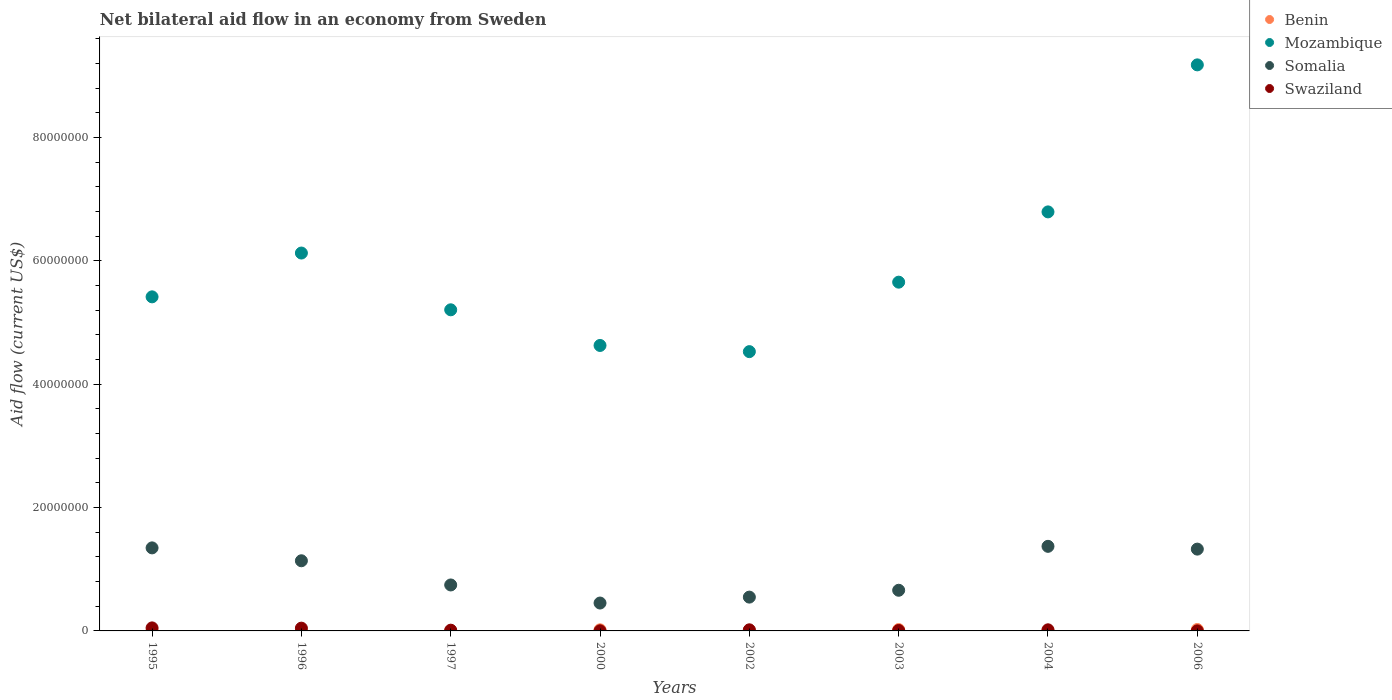Is the number of dotlines equal to the number of legend labels?
Make the answer very short. Yes. What is the net bilateral aid flow in Somalia in 1997?
Ensure brevity in your answer.  7.45e+06. Across all years, what is the maximum net bilateral aid flow in Benin?
Ensure brevity in your answer.  2.30e+05. Across all years, what is the minimum net bilateral aid flow in Mozambique?
Keep it short and to the point. 4.53e+07. In which year was the net bilateral aid flow in Somalia minimum?
Ensure brevity in your answer.  2000. What is the total net bilateral aid flow in Benin in the graph?
Offer a very short reply. 8.80e+05. What is the difference between the net bilateral aid flow in Mozambique in 1996 and that in 2003?
Your answer should be very brief. 4.72e+06. What is the difference between the net bilateral aid flow in Swaziland in 2004 and the net bilateral aid flow in Somalia in 1997?
Offer a terse response. -7.27e+06. What is the average net bilateral aid flow in Mozambique per year?
Make the answer very short. 5.94e+07. In the year 1996, what is the difference between the net bilateral aid flow in Benin and net bilateral aid flow in Somalia?
Your answer should be compact. -1.14e+07. In how many years, is the net bilateral aid flow in Benin greater than 84000000 US$?
Ensure brevity in your answer.  0. What is the ratio of the net bilateral aid flow in Somalia in 1997 to that in 2000?
Your answer should be compact. 1.65. What is the difference between the highest and the second highest net bilateral aid flow in Benin?
Provide a succinct answer. 10000. What is the difference between the highest and the lowest net bilateral aid flow in Mozambique?
Make the answer very short. 4.65e+07. Is the sum of the net bilateral aid flow in Mozambique in 1997 and 2000 greater than the maximum net bilateral aid flow in Somalia across all years?
Provide a succinct answer. Yes. Is it the case that in every year, the sum of the net bilateral aid flow in Benin and net bilateral aid flow in Swaziland  is greater than the sum of net bilateral aid flow in Mozambique and net bilateral aid flow in Somalia?
Provide a short and direct response. No. Does the net bilateral aid flow in Benin monotonically increase over the years?
Make the answer very short. No. Is the net bilateral aid flow in Benin strictly less than the net bilateral aid flow in Somalia over the years?
Offer a terse response. Yes. How many years are there in the graph?
Provide a short and direct response. 8. Does the graph contain grids?
Your answer should be compact. No. Where does the legend appear in the graph?
Provide a succinct answer. Top right. What is the title of the graph?
Provide a short and direct response. Net bilateral aid flow in an economy from Sweden. What is the label or title of the X-axis?
Provide a short and direct response. Years. What is the Aid flow (current US$) of Benin in 1995?
Offer a terse response. 5.00e+04. What is the Aid flow (current US$) of Mozambique in 1995?
Your response must be concise. 5.42e+07. What is the Aid flow (current US$) of Somalia in 1995?
Offer a terse response. 1.35e+07. What is the Aid flow (current US$) in Benin in 1996?
Ensure brevity in your answer.  10000. What is the Aid flow (current US$) in Mozambique in 1996?
Offer a terse response. 6.12e+07. What is the Aid flow (current US$) of Somalia in 1996?
Give a very brief answer. 1.14e+07. What is the Aid flow (current US$) of Swaziland in 1996?
Provide a succinct answer. 4.50e+05. What is the Aid flow (current US$) in Mozambique in 1997?
Your answer should be very brief. 5.20e+07. What is the Aid flow (current US$) of Somalia in 1997?
Give a very brief answer. 7.45e+06. What is the Aid flow (current US$) of Swaziland in 1997?
Give a very brief answer. 1.20e+05. What is the Aid flow (current US$) of Benin in 2000?
Your answer should be compact. 1.80e+05. What is the Aid flow (current US$) of Mozambique in 2000?
Offer a terse response. 4.63e+07. What is the Aid flow (current US$) in Somalia in 2000?
Offer a very short reply. 4.52e+06. What is the Aid flow (current US$) in Swaziland in 2000?
Provide a short and direct response. 2.00e+04. What is the Aid flow (current US$) in Mozambique in 2002?
Provide a succinct answer. 4.53e+07. What is the Aid flow (current US$) in Somalia in 2002?
Your answer should be compact. 5.48e+06. What is the Aid flow (current US$) of Swaziland in 2002?
Keep it short and to the point. 1.80e+05. What is the Aid flow (current US$) in Benin in 2003?
Offer a terse response. 2.20e+05. What is the Aid flow (current US$) of Mozambique in 2003?
Your answer should be very brief. 5.65e+07. What is the Aid flow (current US$) in Somalia in 2003?
Provide a short and direct response. 6.59e+06. What is the Aid flow (current US$) of Swaziland in 2003?
Provide a succinct answer. 7.00e+04. What is the Aid flow (current US$) in Benin in 2004?
Make the answer very short. 9.00e+04. What is the Aid flow (current US$) of Mozambique in 2004?
Your answer should be compact. 6.79e+07. What is the Aid flow (current US$) of Somalia in 2004?
Make the answer very short. 1.37e+07. What is the Aid flow (current US$) in Swaziland in 2004?
Provide a short and direct response. 1.80e+05. What is the Aid flow (current US$) of Benin in 2006?
Your response must be concise. 2.30e+05. What is the Aid flow (current US$) in Mozambique in 2006?
Offer a terse response. 9.18e+07. What is the Aid flow (current US$) of Somalia in 2006?
Make the answer very short. 1.33e+07. Across all years, what is the maximum Aid flow (current US$) of Mozambique?
Offer a terse response. 9.18e+07. Across all years, what is the maximum Aid flow (current US$) in Somalia?
Offer a terse response. 1.37e+07. Across all years, what is the minimum Aid flow (current US$) of Mozambique?
Make the answer very short. 4.53e+07. Across all years, what is the minimum Aid flow (current US$) in Somalia?
Provide a short and direct response. 4.52e+06. What is the total Aid flow (current US$) in Benin in the graph?
Provide a short and direct response. 8.80e+05. What is the total Aid flow (current US$) in Mozambique in the graph?
Your response must be concise. 4.75e+08. What is the total Aid flow (current US$) in Somalia in the graph?
Make the answer very short. 7.58e+07. What is the total Aid flow (current US$) of Swaziland in the graph?
Provide a succinct answer. 1.52e+06. What is the difference between the Aid flow (current US$) in Benin in 1995 and that in 1996?
Give a very brief answer. 4.00e+04. What is the difference between the Aid flow (current US$) in Mozambique in 1995 and that in 1996?
Offer a very short reply. -7.10e+06. What is the difference between the Aid flow (current US$) of Somalia in 1995 and that in 1996?
Ensure brevity in your answer.  2.09e+06. What is the difference between the Aid flow (current US$) of Swaziland in 1995 and that in 1996?
Make the answer very short. 4.00e+04. What is the difference between the Aid flow (current US$) in Benin in 1995 and that in 1997?
Your answer should be compact. 4.00e+04. What is the difference between the Aid flow (current US$) of Mozambique in 1995 and that in 1997?
Your response must be concise. 2.10e+06. What is the difference between the Aid flow (current US$) of Somalia in 1995 and that in 1997?
Keep it short and to the point. 6.01e+06. What is the difference between the Aid flow (current US$) of Swaziland in 1995 and that in 1997?
Your answer should be compact. 3.70e+05. What is the difference between the Aid flow (current US$) of Mozambique in 1995 and that in 2000?
Make the answer very short. 7.88e+06. What is the difference between the Aid flow (current US$) of Somalia in 1995 and that in 2000?
Your answer should be very brief. 8.94e+06. What is the difference between the Aid flow (current US$) in Benin in 1995 and that in 2002?
Your answer should be very brief. -4.00e+04. What is the difference between the Aid flow (current US$) in Mozambique in 1995 and that in 2002?
Offer a terse response. 8.88e+06. What is the difference between the Aid flow (current US$) in Somalia in 1995 and that in 2002?
Your answer should be very brief. 7.98e+06. What is the difference between the Aid flow (current US$) of Swaziland in 1995 and that in 2002?
Offer a terse response. 3.10e+05. What is the difference between the Aid flow (current US$) of Mozambique in 1995 and that in 2003?
Make the answer very short. -2.38e+06. What is the difference between the Aid flow (current US$) of Somalia in 1995 and that in 2003?
Offer a very short reply. 6.87e+06. What is the difference between the Aid flow (current US$) in Benin in 1995 and that in 2004?
Give a very brief answer. -4.00e+04. What is the difference between the Aid flow (current US$) in Mozambique in 1995 and that in 2004?
Keep it short and to the point. -1.38e+07. What is the difference between the Aid flow (current US$) of Somalia in 1995 and that in 2004?
Give a very brief answer. -2.50e+05. What is the difference between the Aid flow (current US$) of Benin in 1995 and that in 2006?
Offer a terse response. -1.80e+05. What is the difference between the Aid flow (current US$) in Mozambique in 1995 and that in 2006?
Offer a terse response. -3.76e+07. What is the difference between the Aid flow (current US$) in Somalia in 1995 and that in 2006?
Your response must be concise. 2.00e+05. What is the difference between the Aid flow (current US$) in Swaziland in 1995 and that in 2006?
Provide a succinct answer. 4.80e+05. What is the difference between the Aid flow (current US$) in Benin in 1996 and that in 1997?
Offer a terse response. 0. What is the difference between the Aid flow (current US$) of Mozambique in 1996 and that in 1997?
Your answer should be compact. 9.20e+06. What is the difference between the Aid flow (current US$) in Somalia in 1996 and that in 1997?
Offer a terse response. 3.92e+06. What is the difference between the Aid flow (current US$) of Swaziland in 1996 and that in 1997?
Give a very brief answer. 3.30e+05. What is the difference between the Aid flow (current US$) of Benin in 1996 and that in 2000?
Ensure brevity in your answer.  -1.70e+05. What is the difference between the Aid flow (current US$) in Mozambique in 1996 and that in 2000?
Offer a terse response. 1.50e+07. What is the difference between the Aid flow (current US$) of Somalia in 1996 and that in 2000?
Your answer should be very brief. 6.85e+06. What is the difference between the Aid flow (current US$) in Swaziland in 1996 and that in 2000?
Offer a very short reply. 4.30e+05. What is the difference between the Aid flow (current US$) of Mozambique in 1996 and that in 2002?
Provide a short and direct response. 1.60e+07. What is the difference between the Aid flow (current US$) of Somalia in 1996 and that in 2002?
Provide a succinct answer. 5.89e+06. What is the difference between the Aid flow (current US$) of Mozambique in 1996 and that in 2003?
Your response must be concise. 4.72e+06. What is the difference between the Aid flow (current US$) of Somalia in 1996 and that in 2003?
Your answer should be compact. 4.78e+06. What is the difference between the Aid flow (current US$) in Mozambique in 1996 and that in 2004?
Provide a succinct answer. -6.67e+06. What is the difference between the Aid flow (current US$) in Somalia in 1996 and that in 2004?
Offer a very short reply. -2.34e+06. What is the difference between the Aid flow (current US$) of Benin in 1996 and that in 2006?
Ensure brevity in your answer.  -2.20e+05. What is the difference between the Aid flow (current US$) in Mozambique in 1996 and that in 2006?
Your answer should be very brief. -3.05e+07. What is the difference between the Aid flow (current US$) in Somalia in 1996 and that in 2006?
Give a very brief answer. -1.89e+06. What is the difference between the Aid flow (current US$) in Mozambique in 1997 and that in 2000?
Provide a succinct answer. 5.78e+06. What is the difference between the Aid flow (current US$) of Somalia in 1997 and that in 2000?
Ensure brevity in your answer.  2.93e+06. What is the difference between the Aid flow (current US$) in Swaziland in 1997 and that in 2000?
Your answer should be compact. 1.00e+05. What is the difference between the Aid flow (current US$) of Benin in 1997 and that in 2002?
Offer a terse response. -8.00e+04. What is the difference between the Aid flow (current US$) in Mozambique in 1997 and that in 2002?
Your answer should be very brief. 6.78e+06. What is the difference between the Aid flow (current US$) in Somalia in 1997 and that in 2002?
Keep it short and to the point. 1.97e+06. What is the difference between the Aid flow (current US$) of Benin in 1997 and that in 2003?
Offer a very short reply. -2.10e+05. What is the difference between the Aid flow (current US$) in Mozambique in 1997 and that in 2003?
Provide a short and direct response. -4.48e+06. What is the difference between the Aid flow (current US$) in Somalia in 1997 and that in 2003?
Offer a very short reply. 8.60e+05. What is the difference between the Aid flow (current US$) of Mozambique in 1997 and that in 2004?
Your response must be concise. -1.59e+07. What is the difference between the Aid flow (current US$) in Somalia in 1997 and that in 2004?
Offer a very short reply. -6.26e+06. What is the difference between the Aid flow (current US$) of Benin in 1997 and that in 2006?
Provide a short and direct response. -2.20e+05. What is the difference between the Aid flow (current US$) of Mozambique in 1997 and that in 2006?
Ensure brevity in your answer.  -3.97e+07. What is the difference between the Aid flow (current US$) of Somalia in 1997 and that in 2006?
Your answer should be compact. -5.81e+06. What is the difference between the Aid flow (current US$) of Somalia in 2000 and that in 2002?
Keep it short and to the point. -9.60e+05. What is the difference between the Aid flow (current US$) of Swaziland in 2000 and that in 2002?
Offer a terse response. -1.60e+05. What is the difference between the Aid flow (current US$) of Benin in 2000 and that in 2003?
Give a very brief answer. -4.00e+04. What is the difference between the Aid flow (current US$) in Mozambique in 2000 and that in 2003?
Give a very brief answer. -1.03e+07. What is the difference between the Aid flow (current US$) of Somalia in 2000 and that in 2003?
Offer a terse response. -2.07e+06. What is the difference between the Aid flow (current US$) in Mozambique in 2000 and that in 2004?
Your answer should be compact. -2.16e+07. What is the difference between the Aid flow (current US$) of Somalia in 2000 and that in 2004?
Offer a terse response. -9.19e+06. What is the difference between the Aid flow (current US$) of Benin in 2000 and that in 2006?
Your answer should be very brief. -5.00e+04. What is the difference between the Aid flow (current US$) in Mozambique in 2000 and that in 2006?
Make the answer very short. -4.55e+07. What is the difference between the Aid flow (current US$) in Somalia in 2000 and that in 2006?
Your answer should be compact. -8.74e+06. What is the difference between the Aid flow (current US$) of Swaziland in 2000 and that in 2006?
Your response must be concise. 10000. What is the difference between the Aid flow (current US$) of Mozambique in 2002 and that in 2003?
Make the answer very short. -1.13e+07. What is the difference between the Aid flow (current US$) in Somalia in 2002 and that in 2003?
Your answer should be compact. -1.11e+06. What is the difference between the Aid flow (current US$) of Benin in 2002 and that in 2004?
Provide a short and direct response. 0. What is the difference between the Aid flow (current US$) of Mozambique in 2002 and that in 2004?
Your answer should be compact. -2.26e+07. What is the difference between the Aid flow (current US$) of Somalia in 2002 and that in 2004?
Offer a very short reply. -8.23e+06. What is the difference between the Aid flow (current US$) in Swaziland in 2002 and that in 2004?
Offer a terse response. 0. What is the difference between the Aid flow (current US$) of Mozambique in 2002 and that in 2006?
Your answer should be very brief. -4.65e+07. What is the difference between the Aid flow (current US$) in Somalia in 2002 and that in 2006?
Give a very brief answer. -7.78e+06. What is the difference between the Aid flow (current US$) of Swaziland in 2002 and that in 2006?
Provide a short and direct response. 1.70e+05. What is the difference between the Aid flow (current US$) in Benin in 2003 and that in 2004?
Offer a terse response. 1.30e+05. What is the difference between the Aid flow (current US$) in Mozambique in 2003 and that in 2004?
Your answer should be compact. -1.14e+07. What is the difference between the Aid flow (current US$) in Somalia in 2003 and that in 2004?
Provide a short and direct response. -7.12e+06. What is the difference between the Aid flow (current US$) in Benin in 2003 and that in 2006?
Give a very brief answer. -10000. What is the difference between the Aid flow (current US$) of Mozambique in 2003 and that in 2006?
Your response must be concise. -3.52e+07. What is the difference between the Aid flow (current US$) of Somalia in 2003 and that in 2006?
Offer a terse response. -6.67e+06. What is the difference between the Aid flow (current US$) of Swaziland in 2003 and that in 2006?
Your response must be concise. 6.00e+04. What is the difference between the Aid flow (current US$) of Mozambique in 2004 and that in 2006?
Keep it short and to the point. -2.38e+07. What is the difference between the Aid flow (current US$) in Somalia in 2004 and that in 2006?
Ensure brevity in your answer.  4.50e+05. What is the difference between the Aid flow (current US$) in Benin in 1995 and the Aid flow (current US$) in Mozambique in 1996?
Keep it short and to the point. -6.12e+07. What is the difference between the Aid flow (current US$) in Benin in 1995 and the Aid flow (current US$) in Somalia in 1996?
Offer a very short reply. -1.13e+07. What is the difference between the Aid flow (current US$) in Benin in 1995 and the Aid flow (current US$) in Swaziland in 1996?
Offer a terse response. -4.00e+05. What is the difference between the Aid flow (current US$) of Mozambique in 1995 and the Aid flow (current US$) of Somalia in 1996?
Make the answer very short. 4.28e+07. What is the difference between the Aid flow (current US$) in Mozambique in 1995 and the Aid flow (current US$) in Swaziland in 1996?
Your answer should be very brief. 5.37e+07. What is the difference between the Aid flow (current US$) of Somalia in 1995 and the Aid flow (current US$) of Swaziland in 1996?
Ensure brevity in your answer.  1.30e+07. What is the difference between the Aid flow (current US$) of Benin in 1995 and the Aid flow (current US$) of Mozambique in 1997?
Give a very brief answer. -5.20e+07. What is the difference between the Aid flow (current US$) in Benin in 1995 and the Aid flow (current US$) in Somalia in 1997?
Make the answer very short. -7.40e+06. What is the difference between the Aid flow (current US$) of Benin in 1995 and the Aid flow (current US$) of Swaziland in 1997?
Your answer should be very brief. -7.00e+04. What is the difference between the Aid flow (current US$) of Mozambique in 1995 and the Aid flow (current US$) of Somalia in 1997?
Your response must be concise. 4.67e+07. What is the difference between the Aid flow (current US$) of Mozambique in 1995 and the Aid flow (current US$) of Swaziland in 1997?
Keep it short and to the point. 5.40e+07. What is the difference between the Aid flow (current US$) of Somalia in 1995 and the Aid flow (current US$) of Swaziland in 1997?
Provide a succinct answer. 1.33e+07. What is the difference between the Aid flow (current US$) in Benin in 1995 and the Aid flow (current US$) in Mozambique in 2000?
Provide a short and direct response. -4.62e+07. What is the difference between the Aid flow (current US$) in Benin in 1995 and the Aid flow (current US$) in Somalia in 2000?
Your answer should be compact. -4.47e+06. What is the difference between the Aid flow (current US$) in Benin in 1995 and the Aid flow (current US$) in Swaziland in 2000?
Provide a short and direct response. 3.00e+04. What is the difference between the Aid flow (current US$) in Mozambique in 1995 and the Aid flow (current US$) in Somalia in 2000?
Provide a short and direct response. 4.96e+07. What is the difference between the Aid flow (current US$) in Mozambique in 1995 and the Aid flow (current US$) in Swaziland in 2000?
Your response must be concise. 5.41e+07. What is the difference between the Aid flow (current US$) of Somalia in 1995 and the Aid flow (current US$) of Swaziland in 2000?
Make the answer very short. 1.34e+07. What is the difference between the Aid flow (current US$) in Benin in 1995 and the Aid flow (current US$) in Mozambique in 2002?
Ensure brevity in your answer.  -4.52e+07. What is the difference between the Aid flow (current US$) in Benin in 1995 and the Aid flow (current US$) in Somalia in 2002?
Provide a succinct answer. -5.43e+06. What is the difference between the Aid flow (current US$) in Benin in 1995 and the Aid flow (current US$) in Swaziland in 2002?
Provide a short and direct response. -1.30e+05. What is the difference between the Aid flow (current US$) of Mozambique in 1995 and the Aid flow (current US$) of Somalia in 2002?
Your answer should be very brief. 4.87e+07. What is the difference between the Aid flow (current US$) of Mozambique in 1995 and the Aid flow (current US$) of Swaziland in 2002?
Give a very brief answer. 5.40e+07. What is the difference between the Aid flow (current US$) of Somalia in 1995 and the Aid flow (current US$) of Swaziland in 2002?
Keep it short and to the point. 1.33e+07. What is the difference between the Aid flow (current US$) in Benin in 1995 and the Aid flow (current US$) in Mozambique in 2003?
Provide a succinct answer. -5.65e+07. What is the difference between the Aid flow (current US$) in Benin in 1995 and the Aid flow (current US$) in Somalia in 2003?
Offer a terse response. -6.54e+06. What is the difference between the Aid flow (current US$) in Mozambique in 1995 and the Aid flow (current US$) in Somalia in 2003?
Offer a very short reply. 4.76e+07. What is the difference between the Aid flow (current US$) in Mozambique in 1995 and the Aid flow (current US$) in Swaziland in 2003?
Give a very brief answer. 5.41e+07. What is the difference between the Aid flow (current US$) in Somalia in 1995 and the Aid flow (current US$) in Swaziland in 2003?
Provide a succinct answer. 1.34e+07. What is the difference between the Aid flow (current US$) of Benin in 1995 and the Aid flow (current US$) of Mozambique in 2004?
Make the answer very short. -6.79e+07. What is the difference between the Aid flow (current US$) of Benin in 1995 and the Aid flow (current US$) of Somalia in 2004?
Ensure brevity in your answer.  -1.37e+07. What is the difference between the Aid flow (current US$) of Benin in 1995 and the Aid flow (current US$) of Swaziland in 2004?
Your answer should be very brief. -1.30e+05. What is the difference between the Aid flow (current US$) of Mozambique in 1995 and the Aid flow (current US$) of Somalia in 2004?
Provide a short and direct response. 4.04e+07. What is the difference between the Aid flow (current US$) of Mozambique in 1995 and the Aid flow (current US$) of Swaziland in 2004?
Offer a terse response. 5.40e+07. What is the difference between the Aid flow (current US$) of Somalia in 1995 and the Aid flow (current US$) of Swaziland in 2004?
Keep it short and to the point. 1.33e+07. What is the difference between the Aid flow (current US$) of Benin in 1995 and the Aid flow (current US$) of Mozambique in 2006?
Provide a short and direct response. -9.17e+07. What is the difference between the Aid flow (current US$) in Benin in 1995 and the Aid flow (current US$) in Somalia in 2006?
Your answer should be compact. -1.32e+07. What is the difference between the Aid flow (current US$) of Mozambique in 1995 and the Aid flow (current US$) of Somalia in 2006?
Your response must be concise. 4.09e+07. What is the difference between the Aid flow (current US$) of Mozambique in 1995 and the Aid flow (current US$) of Swaziland in 2006?
Make the answer very short. 5.41e+07. What is the difference between the Aid flow (current US$) in Somalia in 1995 and the Aid flow (current US$) in Swaziland in 2006?
Make the answer very short. 1.34e+07. What is the difference between the Aid flow (current US$) of Benin in 1996 and the Aid flow (current US$) of Mozambique in 1997?
Give a very brief answer. -5.20e+07. What is the difference between the Aid flow (current US$) in Benin in 1996 and the Aid flow (current US$) in Somalia in 1997?
Give a very brief answer. -7.44e+06. What is the difference between the Aid flow (current US$) of Mozambique in 1996 and the Aid flow (current US$) of Somalia in 1997?
Your response must be concise. 5.38e+07. What is the difference between the Aid flow (current US$) in Mozambique in 1996 and the Aid flow (current US$) in Swaziland in 1997?
Give a very brief answer. 6.11e+07. What is the difference between the Aid flow (current US$) of Somalia in 1996 and the Aid flow (current US$) of Swaziland in 1997?
Offer a terse response. 1.12e+07. What is the difference between the Aid flow (current US$) of Benin in 1996 and the Aid flow (current US$) of Mozambique in 2000?
Your answer should be very brief. -4.63e+07. What is the difference between the Aid flow (current US$) of Benin in 1996 and the Aid flow (current US$) of Somalia in 2000?
Ensure brevity in your answer.  -4.51e+06. What is the difference between the Aid flow (current US$) in Mozambique in 1996 and the Aid flow (current US$) in Somalia in 2000?
Provide a short and direct response. 5.67e+07. What is the difference between the Aid flow (current US$) in Mozambique in 1996 and the Aid flow (current US$) in Swaziland in 2000?
Make the answer very short. 6.12e+07. What is the difference between the Aid flow (current US$) in Somalia in 1996 and the Aid flow (current US$) in Swaziland in 2000?
Make the answer very short. 1.14e+07. What is the difference between the Aid flow (current US$) in Benin in 1996 and the Aid flow (current US$) in Mozambique in 2002?
Provide a succinct answer. -4.53e+07. What is the difference between the Aid flow (current US$) of Benin in 1996 and the Aid flow (current US$) of Somalia in 2002?
Give a very brief answer. -5.47e+06. What is the difference between the Aid flow (current US$) of Mozambique in 1996 and the Aid flow (current US$) of Somalia in 2002?
Offer a terse response. 5.58e+07. What is the difference between the Aid flow (current US$) of Mozambique in 1996 and the Aid flow (current US$) of Swaziland in 2002?
Your answer should be very brief. 6.11e+07. What is the difference between the Aid flow (current US$) in Somalia in 1996 and the Aid flow (current US$) in Swaziland in 2002?
Your response must be concise. 1.12e+07. What is the difference between the Aid flow (current US$) in Benin in 1996 and the Aid flow (current US$) in Mozambique in 2003?
Ensure brevity in your answer.  -5.65e+07. What is the difference between the Aid flow (current US$) of Benin in 1996 and the Aid flow (current US$) of Somalia in 2003?
Keep it short and to the point. -6.58e+06. What is the difference between the Aid flow (current US$) in Mozambique in 1996 and the Aid flow (current US$) in Somalia in 2003?
Give a very brief answer. 5.47e+07. What is the difference between the Aid flow (current US$) in Mozambique in 1996 and the Aid flow (current US$) in Swaziland in 2003?
Give a very brief answer. 6.12e+07. What is the difference between the Aid flow (current US$) in Somalia in 1996 and the Aid flow (current US$) in Swaziland in 2003?
Offer a terse response. 1.13e+07. What is the difference between the Aid flow (current US$) in Benin in 1996 and the Aid flow (current US$) in Mozambique in 2004?
Your answer should be compact. -6.79e+07. What is the difference between the Aid flow (current US$) in Benin in 1996 and the Aid flow (current US$) in Somalia in 2004?
Keep it short and to the point. -1.37e+07. What is the difference between the Aid flow (current US$) in Benin in 1996 and the Aid flow (current US$) in Swaziland in 2004?
Ensure brevity in your answer.  -1.70e+05. What is the difference between the Aid flow (current US$) in Mozambique in 1996 and the Aid flow (current US$) in Somalia in 2004?
Provide a short and direct response. 4.75e+07. What is the difference between the Aid flow (current US$) of Mozambique in 1996 and the Aid flow (current US$) of Swaziland in 2004?
Your answer should be very brief. 6.11e+07. What is the difference between the Aid flow (current US$) in Somalia in 1996 and the Aid flow (current US$) in Swaziland in 2004?
Your answer should be very brief. 1.12e+07. What is the difference between the Aid flow (current US$) in Benin in 1996 and the Aid flow (current US$) in Mozambique in 2006?
Provide a succinct answer. -9.17e+07. What is the difference between the Aid flow (current US$) in Benin in 1996 and the Aid flow (current US$) in Somalia in 2006?
Your answer should be compact. -1.32e+07. What is the difference between the Aid flow (current US$) in Mozambique in 1996 and the Aid flow (current US$) in Somalia in 2006?
Your answer should be compact. 4.80e+07. What is the difference between the Aid flow (current US$) in Mozambique in 1996 and the Aid flow (current US$) in Swaziland in 2006?
Provide a short and direct response. 6.12e+07. What is the difference between the Aid flow (current US$) of Somalia in 1996 and the Aid flow (current US$) of Swaziland in 2006?
Offer a terse response. 1.14e+07. What is the difference between the Aid flow (current US$) of Benin in 1997 and the Aid flow (current US$) of Mozambique in 2000?
Your answer should be very brief. -4.63e+07. What is the difference between the Aid flow (current US$) in Benin in 1997 and the Aid flow (current US$) in Somalia in 2000?
Keep it short and to the point. -4.51e+06. What is the difference between the Aid flow (current US$) in Benin in 1997 and the Aid flow (current US$) in Swaziland in 2000?
Your answer should be compact. -10000. What is the difference between the Aid flow (current US$) in Mozambique in 1997 and the Aid flow (current US$) in Somalia in 2000?
Your response must be concise. 4.75e+07. What is the difference between the Aid flow (current US$) in Mozambique in 1997 and the Aid flow (current US$) in Swaziland in 2000?
Make the answer very short. 5.20e+07. What is the difference between the Aid flow (current US$) of Somalia in 1997 and the Aid flow (current US$) of Swaziland in 2000?
Make the answer very short. 7.43e+06. What is the difference between the Aid flow (current US$) in Benin in 1997 and the Aid flow (current US$) in Mozambique in 2002?
Your answer should be very brief. -4.53e+07. What is the difference between the Aid flow (current US$) of Benin in 1997 and the Aid flow (current US$) of Somalia in 2002?
Offer a terse response. -5.47e+06. What is the difference between the Aid flow (current US$) of Benin in 1997 and the Aid flow (current US$) of Swaziland in 2002?
Offer a very short reply. -1.70e+05. What is the difference between the Aid flow (current US$) of Mozambique in 1997 and the Aid flow (current US$) of Somalia in 2002?
Your response must be concise. 4.66e+07. What is the difference between the Aid flow (current US$) in Mozambique in 1997 and the Aid flow (current US$) in Swaziland in 2002?
Provide a short and direct response. 5.19e+07. What is the difference between the Aid flow (current US$) of Somalia in 1997 and the Aid flow (current US$) of Swaziland in 2002?
Provide a short and direct response. 7.27e+06. What is the difference between the Aid flow (current US$) of Benin in 1997 and the Aid flow (current US$) of Mozambique in 2003?
Your response must be concise. -5.65e+07. What is the difference between the Aid flow (current US$) in Benin in 1997 and the Aid flow (current US$) in Somalia in 2003?
Your response must be concise. -6.58e+06. What is the difference between the Aid flow (current US$) of Benin in 1997 and the Aid flow (current US$) of Swaziland in 2003?
Your answer should be very brief. -6.00e+04. What is the difference between the Aid flow (current US$) of Mozambique in 1997 and the Aid flow (current US$) of Somalia in 2003?
Make the answer very short. 4.55e+07. What is the difference between the Aid flow (current US$) of Mozambique in 1997 and the Aid flow (current US$) of Swaziland in 2003?
Offer a very short reply. 5.20e+07. What is the difference between the Aid flow (current US$) of Somalia in 1997 and the Aid flow (current US$) of Swaziland in 2003?
Offer a terse response. 7.38e+06. What is the difference between the Aid flow (current US$) in Benin in 1997 and the Aid flow (current US$) in Mozambique in 2004?
Ensure brevity in your answer.  -6.79e+07. What is the difference between the Aid flow (current US$) in Benin in 1997 and the Aid flow (current US$) in Somalia in 2004?
Offer a terse response. -1.37e+07. What is the difference between the Aid flow (current US$) in Benin in 1997 and the Aid flow (current US$) in Swaziland in 2004?
Offer a very short reply. -1.70e+05. What is the difference between the Aid flow (current US$) in Mozambique in 1997 and the Aid flow (current US$) in Somalia in 2004?
Give a very brief answer. 3.83e+07. What is the difference between the Aid flow (current US$) of Mozambique in 1997 and the Aid flow (current US$) of Swaziland in 2004?
Keep it short and to the point. 5.19e+07. What is the difference between the Aid flow (current US$) of Somalia in 1997 and the Aid flow (current US$) of Swaziland in 2004?
Make the answer very short. 7.27e+06. What is the difference between the Aid flow (current US$) of Benin in 1997 and the Aid flow (current US$) of Mozambique in 2006?
Provide a succinct answer. -9.17e+07. What is the difference between the Aid flow (current US$) in Benin in 1997 and the Aid flow (current US$) in Somalia in 2006?
Make the answer very short. -1.32e+07. What is the difference between the Aid flow (current US$) in Mozambique in 1997 and the Aid flow (current US$) in Somalia in 2006?
Your response must be concise. 3.88e+07. What is the difference between the Aid flow (current US$) in Mozambique in 1997 and the Aid flow (current US$) in Swaziland in 2006?
Your response must be concise. 5.20e+07. What is the difference between the Aid flow (current US$) in Somalia in 1997 and the Aid flow (current US$) in Swaziland in 2006?
Give a very brief answer. 7.44e+06. What is the difference between the Aid flow (current US$) in Benin in 2000 and the Aid flow (current US$) in Mozambique in 2002?
Provide a succinct answer. -4.51e+07. What is the difference between the Aid flow (current US$) of Benin in 2000 and the Aid flow (current US$) of Somalia in 2002?
Provide a short and direct response. -5.30e+06. What is the difference between the Aid flow (current US$) in Mozambique in 2000 and the Aid flow (current US$) in Somalia in 2002?
Keep it short and to the point. 4.08e+07. What is the difference between the Aid flow (current US$) in Mozambique in 2000 and the Aid flow (current US$) in Swaziland in 2002?
Your answer should be compact. 4.61e+07. What is the difference between the Aid flow (current US$) of Somalia in 2000 and the Aid flow (current US$) of Swaziland in 2002?
Your response must be concise. 4.34e+06. What is the difference between the Aid flow (current US$) of Benin in 2000 and the Aid flow (current US$) of Mozambique in 2003?
Keep it short and to the point. -5.64e+07. What is the difference between the Aid flow (current US$) in Benin in 2000 and the Aid flow (current US$) in Somalia in 2003?
Provide a succinct answer. -6.41e+06. What is the difference between the Aid flow (current US$) in Benin in 2000 and the Aid flow (current US$) in Swaziland in 2003?
Make the answer very short. 1.10e+05. What is the difference between the Aid flow (current US$) in Mozambique in 2000 and the Aid flow (current US$) in Somalia in 2003?
Provide a short and direct response. 3.97e+07. What is the difference between the Aid flow (current US$) in Mozambique in 2000 and the Aid flow (current US$) in Swaziland in 2003?
Offer a very short reply. 4.62e+07. What is the difference between the Aid flow (current US$) in Somalia in 2000 and the Aid flow (current US$) in Swaziland in 2003?
Give a very brief answer. 4.45e+06. What is the difference between the Aid flow (current US$) of Benin in 2000 and the Aid flow (current US$) of Mozambique in 2004?
Your response must be concise. -6.77e+07. What is the difference between the Aid flow (current US$) of Benin in 2000 and the Aid flow (current US$) of Somalia in 2004?
Your response must be concise. -1.35e+07. What is the difference between the Aid flow (current US$) in Mozambique in 2000 and the Aid flow (current US$) in Somalia in 2004?
Give a very brief answer. 3.26e+07. What is the difference between the Aid flow (current US$) in Mozambique in 2000 and the Aid flow (current US$) in Swaziland in 2004?
Keep it short and to the point. 4.61e+07. What is the difference between the Aid flow (current US$) in Somalia in 2000 and the Aid flow (current US$) in Swaziland in 2004?
Keep it short and to the point. 4.34e+06. What is the difference between the Aid flow (current US$) of Benin in 2000 and the Aid flow (current US$) of Mozambique in 2006?
Your response must be concise. -9.16e+07. What is the difference between the Aid flow (current US$) of Benin in 2000 and the Aid flow (current US$) of Somalia in 2006?
Give a very brief answer. -1.31e+07. What is the difference between the Aid flow (current US$) of Mozambique in 2000 and the Aid flow (current US$) of Somalia in 2006?
Offer a very short reply. 3.30e+07. What is the difference between the Aid flow (current US$) in Mozambique in 2000 and the Aid flow (current US$) in Swaziland in 2006?
Make the answer very short. 4.63e+07. What is the difference between the Aid flow (current US$) of Somalia in 2000 and the Aid flow (current US$) of Swaziland in 2006?
Your response must be concise. 4.51e+06. What is the difference between the Aid flow (current US$) in Benin in 2002 and the Aid flow (current US$) in Mozambique in 2003?
Keep it short and to the point. -5.64e+07. What is the difference between the Aid flow (current US$) of Benin in 2002 and the Aid flow (current US$) of Somalia in 2003?
Provide a short and direct response. -6.50e+06. What is the difference between the Aid flow (current US$) of Benin in 2002 and the Aid flow (current US$) of Swaziland in 2003?
Offer a very short reply. 2.00e+04. What is the difference between the Aid flow (current US$) of Mozambique in 2002 and the Aid flow (current US$) of Somalia in 2003?
Give a very brief answer. 3.87e+07. What is the difference between the Aid flow (current US$) in Mozambique in 2002 and the Aid flow (current US$) in Swaziland in 2003?
Provide a succinct answer. 4.52e+07. What is the difference between the Aid flow (current US$) of Somalia in 2002 and the Aid flow (current US$) of Swaziland in 2003?
Ensure brevity in your answer.  5.41e+06. What is the difference between the Aid flow (current US$) of Benin in 2002 and the Aid flow (current US$) of Mozambique in 2004?
Ensure brevity in your answer.  -6.78e+07. What is the difference between the Aid flow (current US$) in Benin in 2002 and the Aid flow (current US$) in Somalia in 2004?
Make the answer very short. -1.36e+07. What is the difference between the Aid flow (current US$) of Mozambique in 2002 and the Aid flow (current US$) of Somalia in 2004?
Your answer should be compact. 3.16e+07. What is the difference between the Aid flow (current US$) of Mozambique in 2002 and the Aid flow (current US$) of Swaziland in 2004?
Give a very brief answer. 4.51e+07. What is the difference between the Aid flow (current US$) of Somalia in 2002 and the Aid flow (current US$) of Swaziland in 2004?
Offer a very short reply. 5.30e+06. What is the difference between the Aid flow (current US$) of Benin in 2002 and the Aid flow (current US$) of Mozambique in 2006?
Ensure brevity in your answer.  -9.17e+07. What is the difference between the Aid flow (current US$) in Benin in 2002 and the Aid flow (current US$) in Somalia in 2006?
Your answer should be compact. -1.32e+07. What is the difference between the Aid flow (current US$) of Benin in 2002 and the Aid flow (current US$) of Swaziland in 2006?
Make the answer very short. 8.00e+04. What is the difference between the Aid flow (current US$) in Mozambique in 2002 and the Aid flow (current US$) in Somalia in 2006?
Ensure brevity in your answer.  3.20e+07. What is the difference between the Aid flow (current US$) in Mozambique in 2002 and the Aid flow (current US$) in Swaziland in 2006?
Your response must be concise. 4.53e+07. What is the difference between the Aid flow (current US$) of Somalia in 2002 and the Aid flow (current US$) of Swaziland in 2006?
Make the answer very short. 5.47e+06. What is the difference between the Aid flow (current US$) of Benin in 2003 and the Aid flow (current US$) of Mozambique in 2004?
Give a very brief answer. -6.77e+07. What is the difference between the Aid flow (current US$) in Benin in 2003 and the Aid flow (current US$) in Somalia in 2004?
Keep it short and to the point. -1.35e+07. What is the difference between the Aid flow (current US$) in Benin in 2003 and the Aid flow (current US$) in Swaziland in 2004?
Give a very brief answer. 4.00e+04. What is the difference between the Aid flow (current US$) in Mozambique in 2003 and the Aid flow (current US$) in Somalia in 2004?
Keep it short and to the point. 4.28e+07. What is the difference between the Aid flow (current US$) in Mozambique in 2003 and the Aid flow (current US$) in Swaziland in 2004?
Your response must be concise. 5.64e+07. What is the difference between the Aid flow (current US$) in Somalia in 2003 and the Aid flow (current US$) in Swaziland in 2004?
Keep it short and to the point. 6.41e+06. What is the difference between the Aid flow (current US$) of Benin in 2003 and the Aid flow (current US$) of Mozambique in 2006?
Your answer should be compact. -9.15e+07. What is the difference between the Aid flow (current US$) of Benin in 2003 and the Aid flow (current US$) of Somalia in 2006?
Your answer should be compact. -1.30e+07. What is the difference between the Aid flow (current US$) of Benin in 2003 and the Aid flow (current US$) of Swaziland in 2006?
Offer a very short reply. 2.10e+05. What is the difference between the Aid flow (current US$) of Mozambique in 2003 and the Aid flow (current US$) of Somalia in 2006?
Offer a very short reply. 4.33e+07. What is the difference between the Aid flow (current US$) in Mozambique in 2003 and the Aid flow (current US$) in Swaziland in 2006?
Provide a short and direct response. 5.65e+07. What is the difference between the Aid flow (current US$) of Somalia in 2003 and the Aid flow (current US$) of Swaziland in 2006?
Your answer should be very brief. 6.58e+06. What is the difference between the Aid flow (current US$) in Benin in 2004 and the Aid flow (current US$) in Mozambique in 2006?
Your response must be concise. -9.17e+07. What is the difference between the Aid flow (current US$) in Benin in 2004 and the Aid flow (current US$) in Somalia in 2006?
Provide a short and direct response. -1.32e+07. What is the difference between the Aid flow (current US$) of Mozambique in 2004 and the Aid flow (current US$) of Somalia in 2006?
Offer a very short reply. 5.47e+07. What is the difference between the Aid flow (current US$) of Mozambique in 2004 and the Aid flow (current US$) of Swaziland in 2006?
Keep it short and to the point. 6.79e+07. What is the difference between the Aid flow (current US$) in Somalia in 2004 and the Aid flow (current US$) in Swaziland in 2006?
Offer a very short reply. 1.37e+07. What is the average Aid flow (current US$) of Benin per year?
Give a very brief answer. 1.10e+05. What is the average Aid flow (current US$) in Mozambique per year?
Provide a succinct answer. 5.94e+07. What is the average Aid flow (current US$) of Somalia per year?
Your answer should be very brief. 9.48e+06. In the year 1995, what is the difference between the Aid flow (current US$) in Benin and Aid flow (current US$) in Mozambique?
Your response must be concise. -5.41e+07. In the year 1995, what is the difference between the Aid flow (current US$) of Benin and Aid flow (current US$) of Somalia?
Offer a very short reply. -1.34e+07. In the year 1995, what is the difference between the Aid flow (current US$) in Benin and Aid flow (current US$) in Swaziland?
Provide a short and direct response. -4.40e+05. In the year 1995, what is the difference between the Aid flow (current US$) in Mozambique and Aid flow (current US$) in Somalia?
Your answer should be very brief. 4.07e+07. In the year 1995, what is the difference between the Aid flow (current US$) of Mozambique and Aid flow (current US$) of Swaziland?
Your answer should be very brief. 5.37e+07. In the year 1995, what is the difference between the Aid flow (current US$) in Somalia and Aid flow (current US$) in Swaziland?
Your answer should be very brief. 1.30e+07. In the year 1996, what is the difference between the Aid flow (current US$) of Benin and Aid flow (current US$) of Mozambique?
Ensure brevity in your answer.  -6.12e+07. In the year 1996, what is the difference between the Aid flow (current US$) in Benin and Aid flow (current US$) in Somalia?
Ensure brevity in your answer.  -1.14e+07. In the year 1996, what is the difference between the Aid flow (current US$) of Benin and Aid flow (current US$) of Swaziland?
Your answer should be very brief. -4.40e+05. In the year 1996, what is the difference between the Aid flow (current US$) in Mozambique and Aid flow (current US$) in Somalia?
Provide a succinct answer. 4.99e+07. In the year 1996, what is the difference between the Aid flow (current US$) of Mozambique and Aid flow (current US$) of Swaziland?
Offer a very short reply. 6.08e+07. In the year 1996, what is the difference between the Aid flow (current US$) in Somalia and Aid flow (current US$) in Swaziland?
Provide a succinct answer. 1.09e+07. In the year 1997, what is the difference between the Aid flow (current US$) of Benin and Aid flow (current US$) of Mozambique?
Give a very brief answer. -5.20e+07. In the year 1997, what is the difference between the Aid flow (current US$) in Benin and Aid flow (current US$) in Somalia?
Your answer should be very brief. -7.44e+06. In the year 1997, what is the difference between the Aid flow (current US$) in Mozambique and Aid flow (current US$) in Somalia?
Ensure brevity in your answer.  4.46e+07. In the year 1997, what is the difference between the Aid flow (current US$) of Mozambique and Aid flow (current US$) of Swaziland?
Make the answer very short. 5.19e+07. In the year 1997, what is the difference between the Aid flow (current US$) in Somalia and Aid flow (current US$) in Swaziland?
Provide a short and direct response. 7.33e+06. In the year 2000, what is the difference between the Aid flow (current US$) of Benin and Aid flow (current US$) of Mozambique?
Make the answer very short. -4.61e+07. In the year 2000, what is the difference between the Aid flow (current US$) in Benin and Aid flow (current US$) in Somalia?
Your answer should be very brief. -4.34e+06. In the year 2000, what is the difference between the Aid flow (current US$) in Mozambique and Aid flow (current US$) in Somalia?
Give a very brief answer. 4.18e+07. In the year 2000, what is the difference between the Aid flow (current US$) in Mozambique and Aid flow (current US$) in Swaziland?
Offer a terse response. 4.62e+07. In the year 2000, what is the difference between the Aid flow (current US$) of Somalia and Aid flow (current US$) of Swaziland?
Offer a very short reply. 4.50e+06. In the year 2002, what is the difference between the Aid flow (current US$) of Benin and Aid flow (current US$) of Mozambique?
Your response must be concise. -4.52e+07. In the year 2002, what is the difference between the Aid flow (current US$) of Benin and Aid flow (current US$) of Somalia?
Provide a succinct answer. -5.39e+06. In the year 2002, what is the difference between the Aid flow (current US$) of Benin and Aid flow (current US$) of Swaziland?
Offer a very short reply. -9.00e+04. In the year 2002, what is the difference between the Aid flow (current US$) in Mozambique and Aid flow (current US$) in Somalia?
Make the answer very short. 3.98e+07. In the year 2002, what is the difference between the Aid flow (current US$) in Mozambique and Aid flow (current US$) in Swaziland?
Provide a short and direct response. 4.51e+07. In the year 2002, what is the difference between the Aid flow (current US$) in Somalia and Aid flow (current US$) in Swaziland?
Make the answer very short. 5.30e+06. In the year 2003, what is the difference between the Aid flow (current US$) in Benin and Aid flow (current US$) in Mozambique?
Give a very brief answer. -5.63e+07. In the year 2003, what is the difference between the Aid flow (current US$) in Benin and Aid flow (current US$) in Somalia?
Provide a short and direct response. -6.37e+06. In the year 2003, what is the difference between the Aid flow (current US$) in Mozambique and Aid flow (current US$) in Somalia?
Provide a short and direct response. 4.99e+07. In the year 2003, what is the difference between the Aid flow (current US$) of Mozambique and Aid flow (current US$) of Swaziland?
Provide a short and direct response. 5.65e+07. In the year 2003, what is the difference between the Aid flow (current US$) of Somalia and Aid flow (current US$) of Swaziland?
Offer a terse response. 6.52e+06. In the year 2004, what is the difference between the Aid flow (current US$) in Benin and Aid flow (current US$) in Mozambique?
Ensure brevity in your answer.  -6.78e+07. In the year 2004, what is the difference between the Aid flow (current US$) of Benin and Aid flow (current US$) of Somalia?
Keep it short and to the point. -1.36e+07. In the year 2004, what is the difference between the Aid flow (current US$) of Mozambique and Aid flow (current US$) of Somalia?
Provide a succinct answer. 5.42e+07. In the year 2004, what is the difference between the Aid flow (current US$) in Mozambique and Aid flow (current US$) in Swaziland?
Your response must be concise. 6.77e+07. In the year 2004, what is the difference between the Aid flow (current US$) of Somalia and Aid flow (current US$) of Swaziland?
Ensure brevity in your answer.  1.35e+07. In the year 2006, what is the difference between the Aid flow (current US$) of Benin and Aid flow (current US$) of Mozambique?
Ensure brevity in your answer.  -9.15e+07. In the year 2006, what is the difference between the Aid flow (current US$) in Benin and Aid flow (current US$) in Somalia?
Give a very brief answer. -1.30e+07. In the year 2006, what is the difference between the Aid flow (current US$) of Mozambique and Aid flow (current US$) of Somalia?
Keep it short and to the point. 7.85e+07. In the year 2006, what is the difference between the Aid flow (current US$) of Mozambique and Aid flow (current US$) of Swaziland?
Your answer should be very brief. 9.17e+07. In the year 2006, what is the difference between the Aid flow (current US$) of Somalia and Aid flow (current US$) of Swaziland?
Your response must be concise. 1.32e+07. What is the ratio of the Aid flow (current US$) of Mozambique in 1995 to that in 1996?
Provide a succinct answer. 0.88. What is the ratio of the Aid flow (current US$) in Somalia in 1995 to that in 1996?
Ensure brevity in your answer.  1.18. What is the ratio of the Aid flow (current US$) of Swaziland in 1995 to that in 1996?
Ensure brevity in your answer.  1.09. What is the ratio of the Aid flow (current US$) of Benin in 1995 to that in 1997?
Keep it short and to the point. 5. What is the ratio of the Aid flow (current US$) of Mozambique in 1995 to that in 1997?
Offer a very short reply. 1.04. What is the ratio of the Aid flow (current US$) in Somalia in 1995 to that in 1997?
Provide a short and direct response. 1.81. What is the ratio of the Aid flow (current US$) in Swaziland in 1995 to that in 1997?
Provide a short and direct response. 4.08. What is the ratio of the Aid flow (current US$) of Benin in 1995 to that in 2000?
Make the answer very short. 0.28. What is the ratio of the Aid flow (current US$) in Mozambique in 1995 to that in 2000?
Provide a short and direct response. 1.17. What is the ratio of the Aid flow (current US$) in Somalia in 1995 to that in 2000?
Offer a very short reply. 2.98. What is the ratio of the Aid flow (current US$) in Swaziland in 1995 to that in 2000?
Keep it short and to the point. 24.5. What is the ratio of the Aid flow (current US$) of Benin in 1995 to that in 2002?
Make the answer very short. 0.56. What is the ratio of the Aid flow (current US$) in Mozambique in 1995 to that in 2002?
Make the answer very short. 1.2. What is the ratio of the Aid flow (current US$) of Somalia in 1995 to that in 2002?
Offer a very short reply. 2.46. What is the ratio of the Aid flow (current US$) of Swaziland in 1995 to that in 2002?
Provide a succinct answer. 2.72. What is the ratio of the Aid flow (current US$) of Benin in 1995 to that in 2003?
Provide a succinct answer. 0.23. What is the ratio of the Aid flow (current US$) in Mozambique in 1995 to that in 2003?
Your response must be concise. 0.96. What is the ratio of the Aid flow (current US$) of Somalia in 1995 to that in 2003?
Offer a very short reply. 2.04. What is the ratio of the Aid flow (current US$) in Benin in 1995 to that in 2004?
Your response must be concise. 0.56. What is the ratio of the Aid flow (current US$) of Mozambique in 1995 to that in 2004?
Your answer should be compact. 0.8. What is the ratio of the Aid flow (current US$) of Somalia in 1995 to that in 2004?
Give a very brief answer. 0.98. What is the ratio of the Aid flow (current US$) in Swaziland in 1995 to that in 2004?
Ensure brevity in your answer.  2.72. What is the ratio of the Aid flow (current US$) in Benin in 1995 to that in 2006?
Offer a very short reply. 0.22. What is the ratio of the Aid flow (current US$) in Mozambique in 1995 to that in 2006?
Offer a very short reply. 0.59. What is the ratio of the Aid flow (current US$) in Somalia in 1995 to that in 2006?
Provide a short and direct response. 1.02. What is the ratio of the Aid flow (current US$) of Swaziland in 1995 to that in 2006?
Offer a very short reply. 49. What is the ratio of the Aid flow (current US$) of Benin in 1996 to that in 1997?
Give a very brief answer. 1. What is the ratio of the Aid flow (current US$) of Mozambique in 1996 to that in 1997?
Your answer should be very brief. 1.18. What is the ratio of the Aid flow (current US$) in Somalia in 1996 to that in 1997?
Offer a terse response. 1.53. What is the ratio of the Aid flow (current US$) in Swaziland in 1996 to that in 1997?
Your answer should be very brief. 3.75. What is the ratio of the Aid flow (current US$) in Benin in 1996 to that in 2000?
Provide a succinct answer. 0.06. What is the ratio of the Aid flow (current US$) of Mozambique in 1996 to that in 2000?
Provide a short and direct response. 1.32. What is the ratio of the Aid flow (current US$) of Somalia in 1996 to that in 2000?
Offer a terse response. 2.52. What is the ratio of the Aid flow (current US$) in Swaziland in 1996 to that in 2000?
Provide a succinct answer. 22.5. What is the ratio of the Aid flow (current US$) in Mozambique in 1996 to that in 2002?
Offer a very short reply. 1.35. What is the ratio of the Aid flow (current US$) in Somalia in 1996 to that in 2002?
Offer a terse response. 2.07. What is the ratio of the Aid flow (current US$) in Swaziland in 1996 to that in 2002?
Offer a very short reply. 2.5. What is the ratio of the Aid flow (current US$) in Benin in 1996 to that in 2003?
Ensure brevity in your answer.  0.05. What is the ratio of the Aid flow (current US$) in Mozambique in 1996 to that in 2003?
Keep it short and to the point. 1.08. What is the ratio of the Aid flow (current US$) of Somalia in 1996 to that in 2003?
Offer a very short reply. 1.73. What is the ratio of the Aid flow (current US$) of Swaziland in 1996 to that in 2003?
Ensure brevity in your answer.  6.43. What is the ratio of the Aid flow (current US$) in Benin in 1996 to that in 2004?
Offer a very short reply. 0.11. What is the ratio of the Aid flow (current US$) in Mozambique in 1996 to that in 2004?
Make the answer very short. 0.9. What is the ratio of the Aid flow (current US$) of Somalia in 1996 to that in 2004?
Your answer should be compact. 0.83. What is the ratio of the Aid flow (current US$) of Swaziland in 1996 to that in 2004?
Offer a very short reply. 2.5. What is the ratio of the Aid flow (current US$) of Benin in 1996 to that in 2006?
Make the answer very short. 0.04. What is the ratio of the Aid flow (current US$) in Mozambique in 1996 to that in 2006?
Make the answer very short. 0.67. What is the ratio of the Aid flow (current US$) of Somalia in 1996 to that in 2006?
Provide a succinct answer. 0.86. What is the ratio of the Aid flow (current US$) of Benin in 1997 to that in 2000?
Your answer should be compact. 0.06. What is the ratio of the Aid flow (current US$) in Mozambique in 1997 to that in 2000?
Your answer should be compact. 1.12. What is the ratio of the Aid flow (current US$) of Somalia in 1997 to that in 2000?
Ensure brevity in your answer.  1.65. What is the ratio of the Aid flow (current US$) of Swaziland in 1997 to that in 2000?
Your response must be concise. 6. What is the ratio of the Aid flow (current US$) in Benin in 1997 to that in 2002?
Offer a very short reply. 0.11. What is the ratio of the Aid flow (current US$) of Mozambique in 1997 to that in 2002?
Give a very brief answer. 1.15. What is the ratio of the Aid flow (current US$) of Somalia in 1997 to that in 2002?
Your answer should be compact. 1.36. What is the ratio of the Aid flow (current US$) in Swaziland in 1997 to that in 2002?
Offer a terse response. 0.67. What is the ratio of the Aid flow (current US$) of Benin in 1997 to that in 2003?
Your response must be concise. 0.05. What is the ratio of the Aid flow (current US$) in Mozambique in 1997 to that in 2003?
Keep it short and to the point. 0.92. What is the ratio of the Aid flow (current US$) of Somalia in 1997 to that in 2003?
Give a very brief answer. 1.13. What is the ratio of the Aid flow (current US$) of Swaziland in 1997 to that in 2003?
Your response must be concise. 1.71. What is the ratio of the Aid flow (current US$) of Mozambique in 1997 to that in 2004?
Offer a very short reply. 0.77. What is the ratio of the Aid flow (current US$) of Somalia in 1997 to that in 2004?
Give a very brief answer. 0.54. What is the ratio of the Aid flow (current US$) of Benin in 1997 to that in 2006?
Provide a short and direct response. 0.04. What is the ratio of the Aid flow (current US$) in Mozambique in 1997 to that in 2006?
Ensure brevity in your answer.  0.57. What is the ratio of the Aid flow (current US$) of Somalia in 1997 to that in 2006?
Your answer should be very brief. 0.56. What is the ratio of the Aid flow (current US$) of Mozambique in 2000 to that in 2002?
Your answer should be very brief. 1.02. What is the ratio of the Aid flow (current US$) of Somalia in 2000 to that in 2002?
Your response must be concise. 0.82. What is the ratio of the Aid flow (current US$) in Benin in 2000 to that in 2003?
Keep it short and to the point. 0.82. What is the ratio of the Aid flow (current US$) in Mozambique in 2000 to that in 2003?
Your response must be concise. 0.82. What is the ratio of the Aid flow (current US$) in Somalia in 2000 to that in 2003?
Offer a very short reply. 0.69. What is the ratio of the Aid flow (current US$) of Swaziland in 2000 to that in 2003?
Give a very brief answer. 0.29. What is the ratio of the Aid flow (current US$) of Mozambique in 2000 to that in 2004?
Give a very brief answer. 0.68. What is the ratio of the Aid flow (current US$) in Somalia in 2000 to that in 2004?
Provide a short and direct response. 0.33. What is the ratio of the Aid flow (current US$) of Swaziland in 2000 to that in 2004?
Your answer should be compact. 0.11. What is the ratio of the Aid flow (current US$) in Benin in 2000 to that in 2006?
Make the answer very short. 0.78. What is the ratio of the Aid flow (current US$) of Mozambique in 2000 to that in 2006?
Give a very brief answer. 0.5. What is the ratio of the Aid flow (current US$) of Somalia in 2000 to that in 2006?
Offer a terse response. 0.34. What is the ratio of the Aid flow (current US$) in Swaziland in 2000 to that in 2006?
Offer a very short reply. 2. What is the ratio of the Aid flow (current US$) in Benin in 2002 to that in 2003?
Give a very brief answer. 0.41. What is the ratio of the Aid flow (current US$) of Mozambique in 2002 to that in 2003?
Ensure brevity in your answer.  0.8. What is the ratio of the Aid flow (current US$) of Somalia in 2002 to that in 2003?
Your response must be concise. 0.83. What is the ratio of the Aid flow (current US$) of Swaziland in 2002 to that in 2003?
Make the answer very short. 2.57. What is the ratio of the Aid flow (current US$) in Benin in 2002 to that in 2004?
Give a very brief answer. 1. What is the ratio of the Aid flow (current US$) in Mozambique in 2002 to that in 2004?
Provide a succinct answer. 0.67. What is the ratio of the Aid flow (current US$) in Somalia in 2002 to that in 2004?
Ensure brevity in your answer.  0.4. What is the ratio of the Aid flow (current US$) of Benin in 2002 to that in 2006?
Provide a succinct answer. 0.39. What is the ratio of the Aid flow (current US$) of Mozambique in 2002 to that in 2006?
Keep it short and to the point. 0.49. What is the ratio of the Aid flow (current US$) of Somalia in 2002 to that in 2006?
Give a very brief answer. 0.41. What is the ratio of the Aid flow (current US$) in Benin in 2003 to that in 2004?
Provide a succinct answer. 2.44. What is the ratio of the Aid flow (current US$) in Mozambique in 2003 to that in 2004?
Provide a succinct answer. 0.83. What is the ratio of the Aid flow (current US$) of Somalia in 2003 to that in 2004?
Ensure brevity in your answer.  0.48. What is the ratio of the Aid flow (current US$) of Swaziland in 2003 to that in 2004?
Make the answer very short. 0.39. What is the ratio of the Aid flow (current US$) of Benin in 2003 to that in 2006?
Your answer should be compact. 0.96. What is the ratio of the Aid flow (current US$) in Mozambique in 2003 to that in 2006?
Provide a short and direct response. 0.62. What is the ratio of the Aid flow (current US$) in Somalia in 2003 to that in 2006?
Offer a very short reply. 0.5. What is the ratio of the Aid flow (current US$) in Benin in 2004 to that in 2006?
Keep it short and to the point. 0.39. What is the ratio of the Aid flow (current US$) in Mozambique in 2004 to that in 2006?
Ensure brevity in your answer.  0.74. What is the ratio of the Aid flow (current US$) of Somalia in 2004 to that in 2006?
Offer a very short reply. 1.03. What is the ratio of the Aid flow (current US$) in Swaziland in 2004 to that in 2006?
Provide a short and direct response. 18. What is the difference between the highest and the second highest Aid flow (current US$) of Benin?
Your response must be concise. 10000. What is the difference between the highest and the second highest Aid flow (current US$) of Mozambique?
Provide a succinct answer. 2.38e+07. What is the difference between the highest and the second highest Aid flow (current US$) of Swaziland?
Your answer should be very brief. 4.00e+04. What is the difference between the highest and the lowest Aid flow (current US$) in Benin?
Make the answer very short. 2.20e+05. What is the difference between the highest and the lowest Aid flow (current US$) of Mozambique?
Keep it short and to the point. 4.65e+07. What is the difference between the highest and the lowest Aid flow (current US$) in Somalia?
Provide a short and direct response. 9.19e+06. What is the difference between the highest and the lowest Aid flow (current US$) in Swaziland?
Make the answer very short. 4.80e+05. 